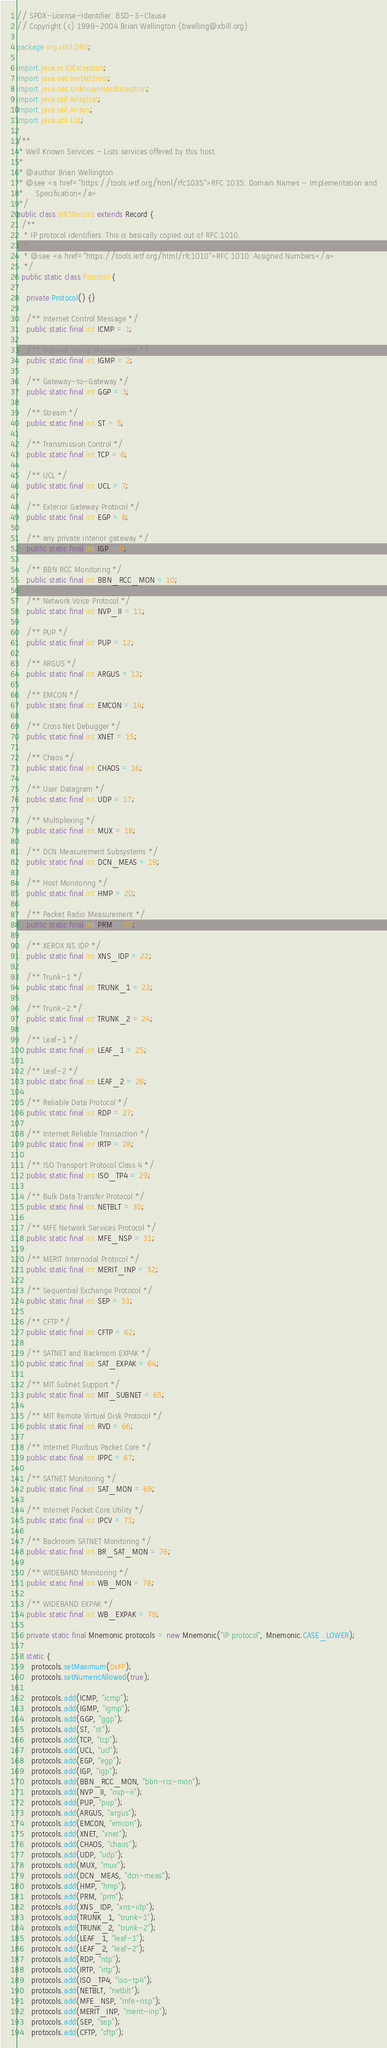Convert code to text. <code><loc_0><loc_0><loc_500><loc_500><_Java_>// SPDX-License-Identifier: BSD-3-Clause
// Copyright (c) 1999-2004 Brian Wellington (bwelling@xbill.org)

package org.xbill.DNS;

import java.io.IOException;
import java.net.InetAddress;
import java.net.UnknownHostException;
import java.util.ArrayList;
import java.util.Arrays;
import java.util.List;

/**
 * Well Known Services - Lists services offered by this host.
 *
 * @author Brian Wellington
 * @see <a href="https://tools.ietf.org/html/rfc1035">RFC 1035: Domain Names - Implementation and
 *     Specification</a>
 */
public class WKSRecord extends Record {
  /**
   * IP protocol identifiers. This is basically copied out of RFC 1010.
   *
   * @see <a href="https://tools.ietf.org/html/rfc1010">RFC 1010: Assigned Numbers</a>
   */
  public static class Protocol {

    private Protocol() {}

    /** Internet Control Message */
    public static final int ICMP = 1;

    /** Internet Group Management */
    public static final int IGMP = 2;

    /** Gateway-to-Gateway */
    public static final int GGP = 3;

    /** Stream */
    public static final int ST = 5;

    /** Transmission Control */
    public static final int TCP = 6;

    /** UCL */
    public static final int UCL = 7;

    /** Exterior Gateway Protocol */
    public static final int EGP = 8;

    /** any private interior gateway */
    public static final int IGP = 9;

    /** BBN RCC Monitoring */
    public static final int BBN_RCC_MON = 10;

    /** Network Voice Protocol */
    public static final int NVP_II = 11;

    /** PUP */
    public static final int PUP = 12;

    /** ARGUS */
    public static final int ARGUS = 13;

    /** EMCON */
    public static final int EMCON = 14;

    /** Cross Net Debugger */
    public static final int XNET = 15;

    /** Chaos */
    public static final int CHAOS = 16;

    /** User Datagram */
    public static final int UDP = 17;

    /** Multiplexing */
    public static final int MUX = 18;

    /** DCN Measurement Subsystems */
    public static final int DCN_MEAS = 19;

    /** Host Monitoring */
    public static final int HMP = 20;

    /** Packet Radio Measurement */
    public static final int PRM = 21;

    /** XEROX NS IDP */
    public static final int XNS_IDP = 22;

    /** Trunk-1 */
    public static final int TRUNK_1 = 23;

    /** Trunk-2 */
    public static final int TRUNK_2 = 24;

    /** Leaf-1 */
    public static final int LEAF_1 = 25;

    /** Leaf-2 */
    public static final int LEAF_2 = 26;

    /** Reliable Data Protocol */
    public static final int RDP = 27;

    /** Internet Reliable Transaction */
    public static final int IRTP = 28;

    /** ISO Transport Protocol Class 4 */
    public static final int ISO_TP4 = 29;

    /** Bulk Data Transfer Protocol */
    public static final int NETBLT = 30;

    /** MFE Network Services Protocol */
    public static final int MFE_NSP = 31;

    /** MERIT Internodal Protocol */
    public static final int MERIT_INP = 32;

    /** Sequential Exchange Protocol */
    public static final int SEP = 33;

    /** CFTP */
    public static final int CFTP = 62;

    /** SATNET and Backroom EXPAK */
    public static final int SAT_EXPAK = 64;

    /** MIT Subnet Support */
    public static final int MIT_SUBNET = 65;

    /** MIT Remote Virtual Disk Protocol */
    public static final int RVD = 66;

    /** Internet Pluribus Packet Core */
    public static final int IPPC = 67;

    /** SATNET Monitoring */
    public static final int SAT_MON = 69;

    /** Internet Packet Core Utility */
    public static final int IPCV = 71;

    /** Backroom SATNET Monitoring */
    public static final int BR_SAT_MON = 76;

    /** WIDEBAND Monitoring */
    public static final int WB_MON = 78;

    /** WIDEBAND EXPAK */
    public static final int WB_EXPAK = 79;

    private static final Mnemonic protocols = new Mnemonic("IP protocol", Mnemonic.CASE_LOWER);

    static {
      protocols.setMaximum(0xFF);
      protocols.setNumericAllowed(true);

      protocols.add(ICMP, "icmp");
      protocols.add(IGMP, "igmp");
      protocols.add(GGP, "ggp");
      protocols.add(ST, "st");
      protocols.add(TCP, "tcp");
      protocols.add(UCL, "ucl");
      protocols.add(EGP, "egp");
      protocols.add(IGP, "igp");
      protocols.add(BBN_RCC_MON, "bbn-rcc-mon");
      protocols.add(NVP_II, "nvp-ii");
      protocols.add(PUP, "pup");
      protocols.add(ARGUS, "argus");
      protocols.add(EMCON, "emcon");
      protocols.add(XNET, "xnet");
      protocols.add(CHAOS, "chaos");
      protocols.add(UDP, "udp");
      protocols.add(MUX, "mux");
      protocols.add(DCN_MEAS, "dcn-meas");
      protocols.add(HMP, "hmp");
      protocols.add(PRM, "prm");
      protocols.add(XNS_IDP, "xns-idp");
      protocols.add(TRUNK_1, "trunk-1");
      protocols.add(TRUNK_2, "trunk-2");
      protocols.add(LEAF_1, "leaf-1");
      protocols.add(LEAF_2, "leaf-2");
      protocols.add(RDP, "rdp");
      protocols.add(IRTP, "irtp");
      protocols.add(ISO_TP4, "iso-tp4");
      protocols.add(NETBLT, "netblt");
      protocols.add(MFE_NSP, "mfe-nsp");
      protocols.add(MERIT_INP, "merit-inp");
      protocols.add(SEP, "sep");
      protocols.add(CFTP, "cftp");</code> 